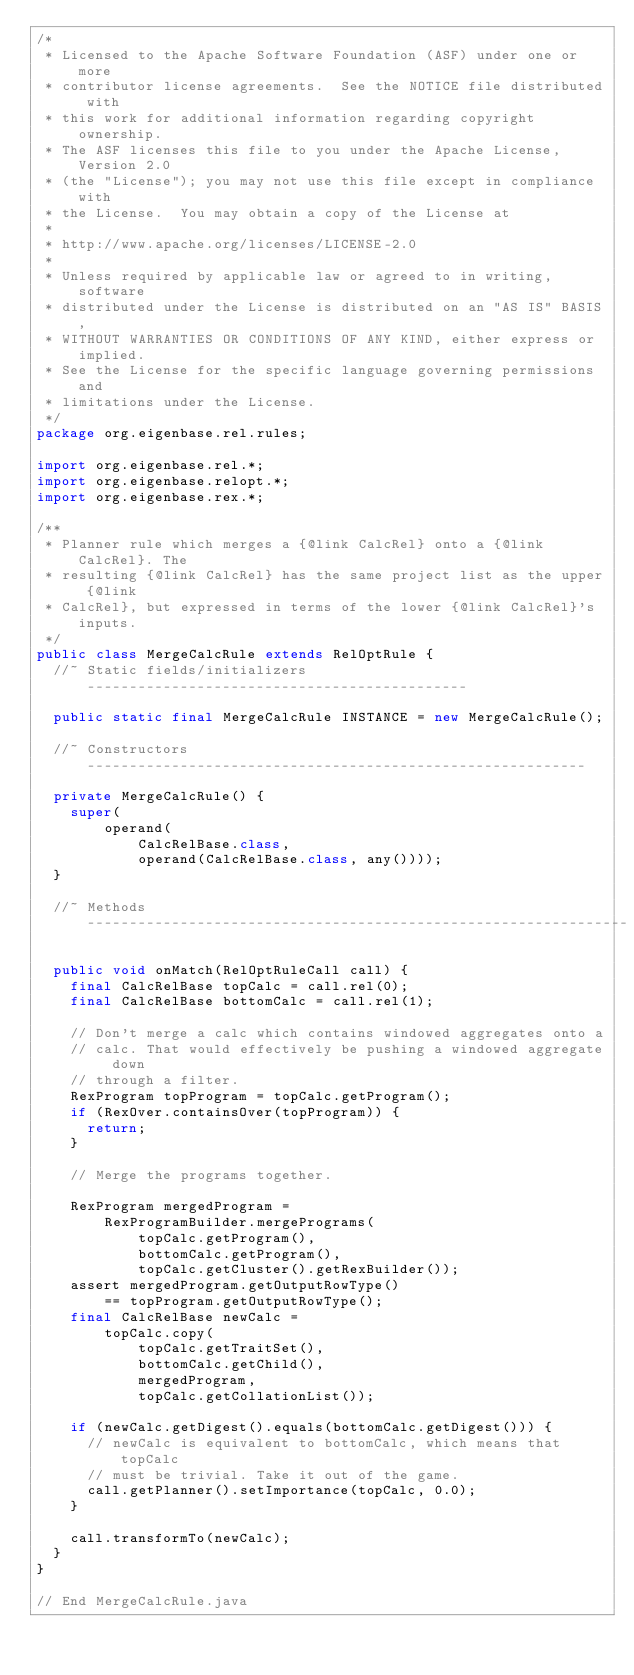<code> <loc_0><loc_0><loc_500><loc_500><_Java_>/*
 * Licensed to the Apache Software Foundation (ASF) under one or more
 * contributor license agreements.  See the NOTICE file distributed with
 * this work for additional information regarding copyright ownership.
 * The ASF licenses this file to you under the Apache License, Version 2.0
 * (the "License"); you may not use this file except in compliance with
 * the License.  You may obtain a copy of the License at
 *
 * http://www.apache.org/licenses/LICENSE-2.0
 *
 * Unless required by applicable law or agreed to in writing, software
 * distributed under the License is distributed on an "AS IS" BASIS,
 * WITHOUT WARRANTIES OR CONDITIONS OF ANY KIND, either express or implied.
 * See the License for the specific language governing permissions and
 * limitations under the License.
 */
package org.eigenbase.rel.rules;

import org.eigenbase.rel.*;
import org.eigenbase.relopt.*;
import org.eigenbase.rex.*;

/**
 * Planner rule which merges a {@link CalcRel} onto a {@link CalcRel}. The
 * resulting {@link CalcRel} has the same project list as the upper {@link
 * CalcRel}, but expressed in terms of the lower {@link CalcRel}'s inputs.
 */
public class MergeCalcRule extends RelOptRule {
  //~ Static fields/initializers ---------------------------------------------

  public static final MergeCalcRule INSTANCE = new MergeCalcRule();

  //~ Constructors -----------------------------------------------------------

  private MergeCalcRule() {
    super(
        operand(
            CalcRelBase.class,
            operand(CalcRelBase.class, any())));
  }

  //~ Methods ----------------------------------------------------------------

  public void onMatch(RelOptRuleCall call) {
    final CalcRelBase topCalc = call.rel(0);
    final CalcRelBase bottomCalc = call.rel(1);

    // Don't merge a calc which contains windowed aggregates onto a
    // calc. That would effectively be pushing a windowed aggregate down
    // through a filter.
    RexProgram topProgram = topCalc.getProgram();
    if (RexOver.containsOver(topProgram)) {
      return;
    }

    // Merge the programs together.

    RexProgram mergedProgram =
        RexProgramBuilder.mergePrograms(
            topCalc.getProgram(),
            bottomCalc.getProgram(),
            topCalc.getCluster().getRexBuilder());
    assert mergedProgram.getOutputRowType()
        == topProgram.getOutputRowType();
    final CalcRelBase newCalc =
        topCalc.copy(
            topCalc.getTraitSet(),
            bottomCalc.getChild(),
            mergedProgram,
            topCalc.getCollationList());

    if (newCalc.getDigest().equals(bottomCalc.getDigest())) {
      // newCalc is equivalent to bottomCalc, which means that topCalc
      // must be trivial. Take it out of the game.
      call.getPlanner().setImportance(topCalc, 0.0);
    }

    call.transformTo(newCalc);
  }
}

// End MergeCalcRule.java
</code> 